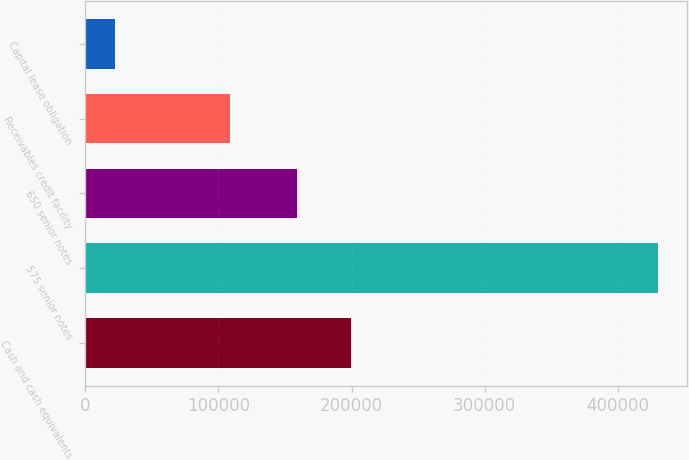Convert chart. <chart><loc_0><loc_0><loc_500><loc_500><bar_chart><fcel>Cash and cash equivalents<fcel>575 senior notes<fcel>650 senior notes<fcel>Receivables credit facility<fcel>Capital lease obligation<nl><fcel>199596<fcel>430464<fcel>158800<fcel>109000<fcel>22502<nl></chart> 